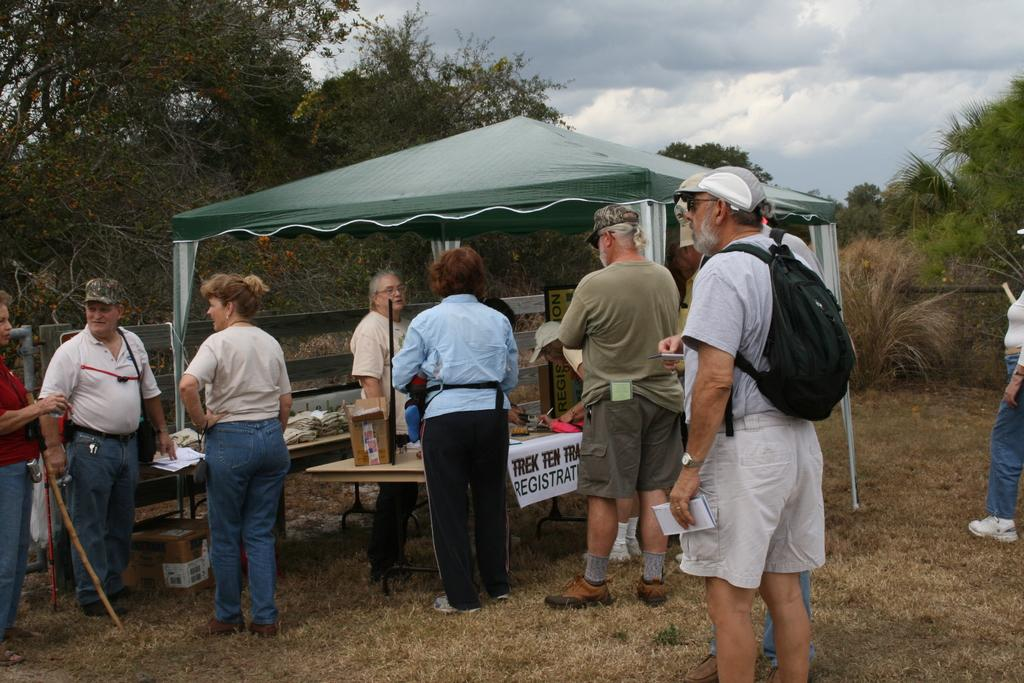What are the people in the image doing? The people in the image are standing in a group. What can be seen on some of the people in the image? Some of the people are wearing backpacks. What structure is present in the image? There is a table under a tent in the image. What type of natural scenery is visible in the background of the image? There are trees visible in the background of the image. Can you tell me how many water bottles are on the hill in the image? There is no hill or water bottles present in the image. What type of experience are the people having in the image? The image does not provide information about the experience of the people; it only shows them standing in a group. 